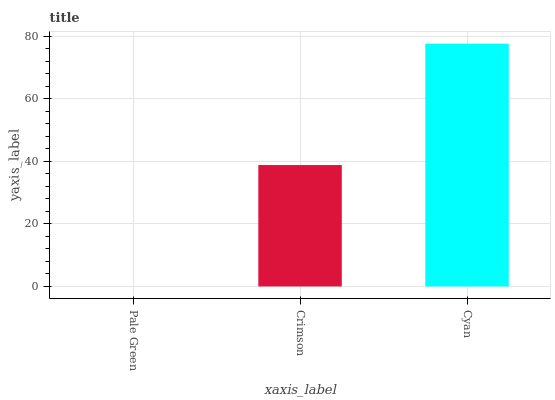Is Pale Green the minimum?
Answer yes or no. Yes. Is Cyan the maximum?
Answer yes or no. Yes. Is Crimson the minimum?
Answer yes or no. No. Is Crimson the maximum?
Answer yes or no. No. Is Crimson greater than Pale Green?
Answer yes or no. Yes. Is Pale Green less than Crimson?
Answer yes or no. Yes. Is Pale Green greater than Crimson?
Answer yes or no. No. Is Crimson less than Pale Green?
Answer yes or no. No. Is Crimson the high median?
Answer yes or no. Yes. Is Crimson the low median?
Answer yes or no. Yes. Is Pale Green the high median?
Answer yes or no. No. Is Cyan the low median?
Answer yes or no. No. 